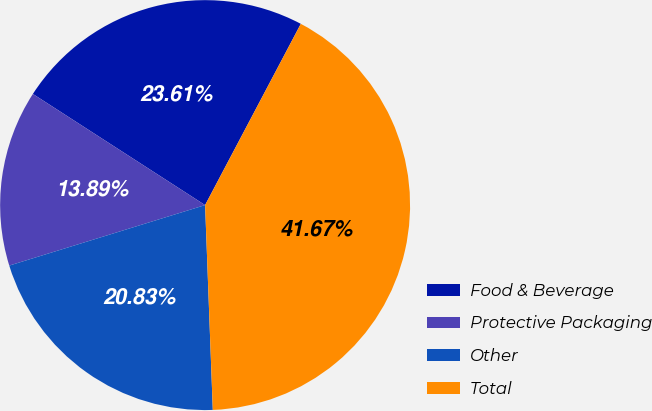<chart> <loc_0><loc_0><loc_500><loc_500><pie_chart><fcel>Food & Beverage<fcel>Protective Packaging<fcel>Other<fcel>Total<nl><fcel>23.61%<fcel>13.89%<fcel>20.83%<fcel>41.67%<nl></chart> 